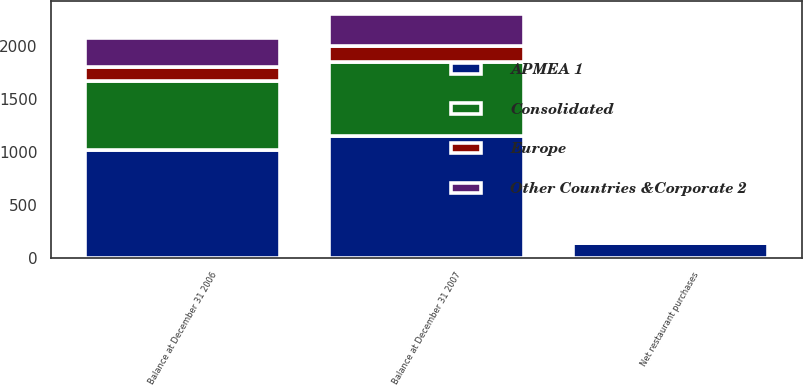Convert chart to OTSL. <chart><loc_0><loc_0><loc_500><loc_500><stacked_bar_chart><ecel><fcel>Balance at December 31 2006<fcel>Net restaurant purchases<fcel>Balance at December 31 2007<nl><fcel>APMEA 1<fcel>1012.8<fcel>133.7<fcel>1146.5<nl><fcel>Consolidated<fcel>652.4<fcel>5.5<fcel>700.2<nl><fcel>Other Countries &Corporate 2<fcel>277.9<fcel>1.2<fcel>306.1<nl><fcel>Europe<fcel>130.5<fcel>4.7<fcel>148.5<nl></chart> 